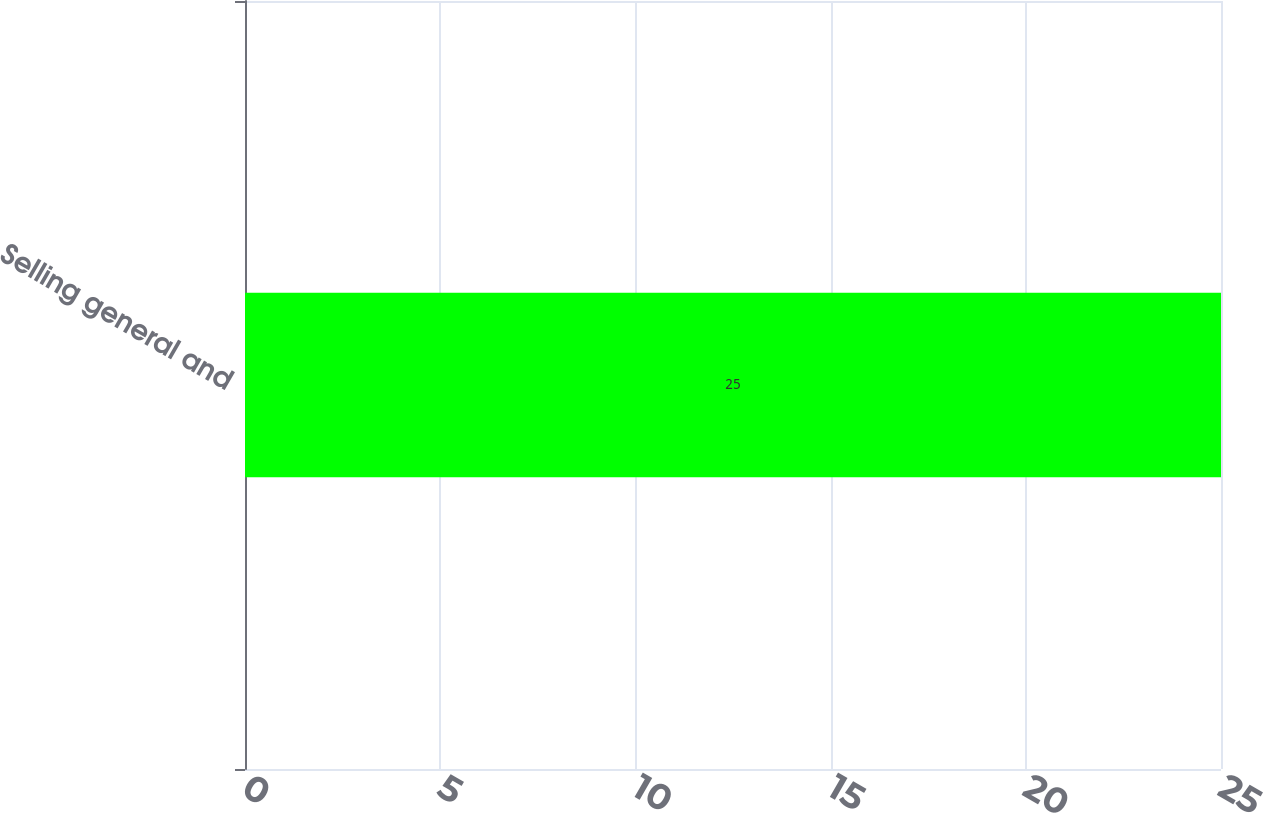Convert chart. <chart><loc_0><loc_0><loc_500><loc_500><bar_chart><fcel>Selling general and<nl><fcel>25<nl></chart> 